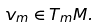<formula> <loc_0><loc_0><loc_500><loc_500>v _ { m } \in T _ { m } M .</formula> 